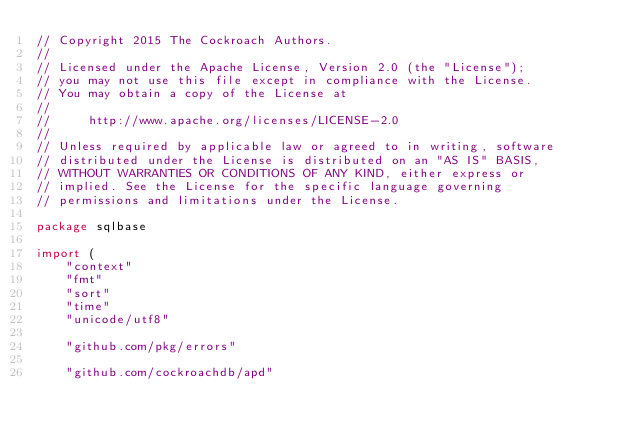<code> <loc_0><loc_0><loc_500><loc_500><_Go_>// Copyright 2015 The Cockroach Authors.
//
// Licensed under the Apache License, Version 2.0 (the "License");
// you may not use this file except in compliance with the License.
// You may obtain a copy of the License at
//
//     http://www.apache.org/licenses/LICENSE-2.0
//
// Unless required by applicable law or agreed to in writing, software
// distributed under the License is distributed on an "AS IS" BASIS,
// WITHOUT WARRANTIES OR CONDITIONS OF ANY KIND, either express or
// implied. See the License for the specific language governing
// permissions and limitations under the License.

package sqlbase

import (
	"context"
	"fmt"
	"sort"
	"time"
	"unicode/utf8"

	"github.com/pkg/errors"

	"github.com/cockroachdb/apd"</code> 